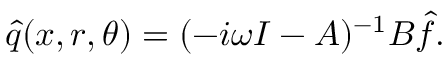Convert formula to latex. <formula><loc_0><loc_0><loc_500><loc_500>\hat { q } ( x , r , \theta ) = ( - i \omega I - A ) ^ { - 1 } B \hat { f } .</formula> 